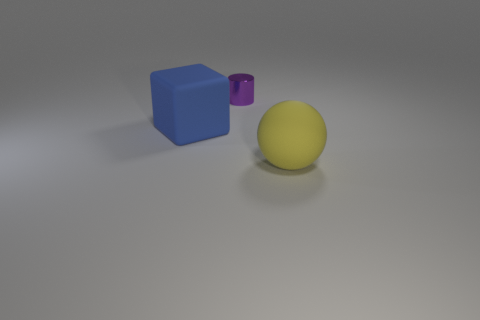How many things are rubber cubes or objects that are behind the big yellow thing?
Your answer should be very brief. 2. There is a large thing that is in front of the block; are there any purple shiny cylinders to the left of it?
Offer a very short reply. Yes. What is the color of the large rubber thing that is to the left of the small purple metallic cylinder?
Your answer should be very brief. Blue. Is the number of small shiny objects in front of the rubber block the same as the number of red cylinders?
Give a very brief answer. Yes. What shape is the thing that is on the right side of the big cube and in front of the metallic object?
Make the answer very short. Sphere. Is there any other thing of the same color as the tiny thing?
Ensure brevity in your answer.  No. There is a big matte object that is to the left of the big thing that is in front of the matte thing left of the yellow thing; what is its shape?
Provide a short and direct response. Cube. There is a rubber thing right of the purple shiny thing; is its size the same as the matte thing that is behind the large rubber sphere?
Provide a short and direct response. Yes. What number of purple cylinders have the same material as the large blue thing?
Keep it short and to the point. 0. There is a matte object right of the large object that is left of the small purple shiny thing; what number of large rubber things are behind it?
Offer a very short reply. 1. 